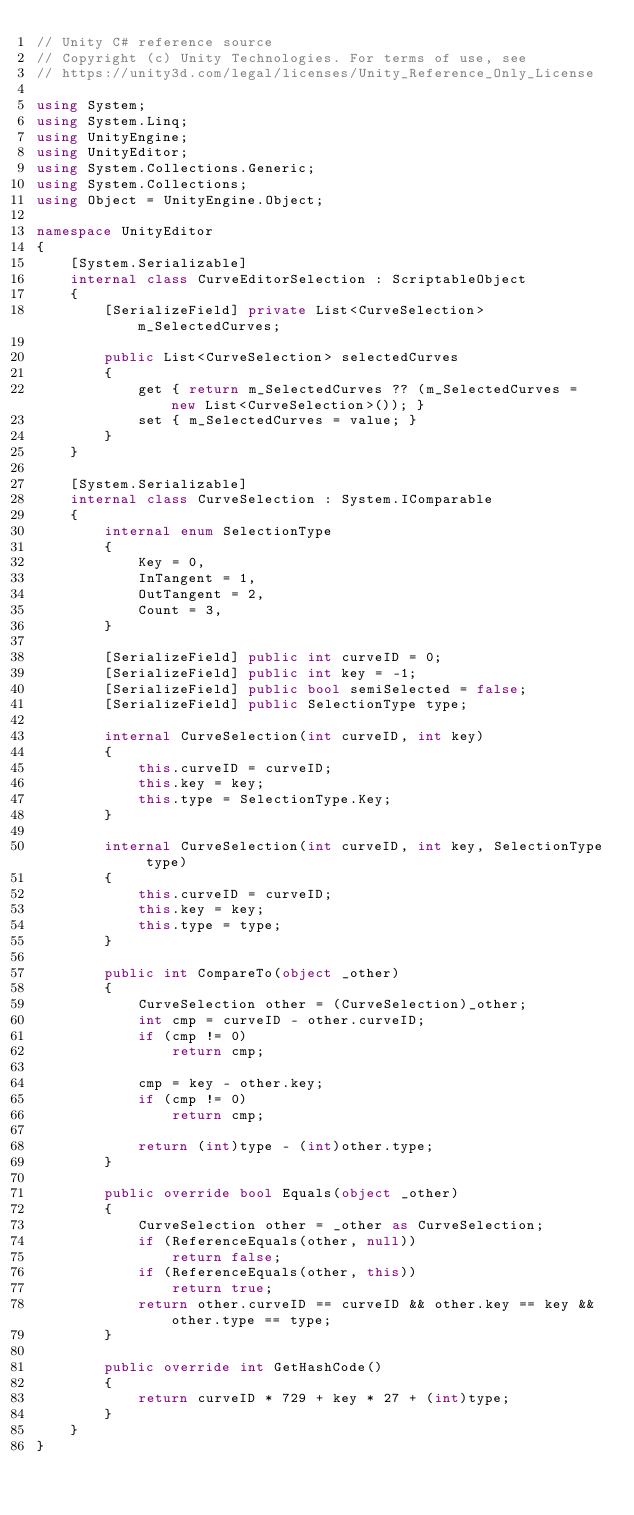Convert code to text. <code><loc_0><loc_0><loc_500><loc_500><_C#_>// Unity C# reference source
// Copyright (c) Unity Technologies. For terms of use, see
// https://unity3d.com/legal/licenses/Unity_Reference_Only_License

using System;
using System.Linq;
using UnityEngine;
using UnityEditor;
using System.Collections.Generic;
using System.Collections;
using Object = UnityEngine.Object;

namespace UnityEditor
{
    [System.Serializable]
    internal class CurveEditorSelection : ScriptableObject
    {
        [SerializeField] private List<CurveSelection> m_SelectedCurves;

        public List<CurveSelection> selectedCurves
        {
            get { return m_SelectedCurves ?? (m_SelectedCurves = new List<CurveSelection>()); }
            set { m_SelectedCurves = value; }
        }
    }

    [System.Serializable]
    internal class CurveSelection : System.IComparable
    {
        internal enum SelectionType
        {
            Key = 0,
            InTangent = 1,
            OutTangent = 2,
            Count = 3,
        }

        [SerializeField] public int curveID = 0;
        [SerializeField] public int key = -1;
        [SerializeField] public bool semiSelected = false;
        [SerializeField] public SelectionType type;

        internal CurveSelection(int curveID, int key)
        {
            this.curveID = curveID;
            this.key = key;
            this.type = SelectionType.Key;
        }

        internal CurveSelection(int curveID, int key, SelectionType type)
        {
            this.curveID = curveID;
            this.key = key;
            this.type = type;
        }

        public int CompareTo(object _other)
        {
            CurveSelection other = (CurveSelection)_other;
            int cmp = curveID - other.curveID;
            if (cmp != 0)
                return cmp;

            cmp = key - other.key;
            if (cmp != 0)
                return cmp;

            return (int)type - (int)other.type;
        }

        public override bool Equals(object _other)
        {
            CurveSelection other = _other as CurveSelection;
            if (ReferenceEquals(other, null))
                return false;
            if (ReferenceEquals(other, this))
                return true;
            return other.curveID == curveID && other.key == key && other.type == type;
        }

        public override int GetHashCode()
        {
            return curveID * 729 + key * 27 + (int)type;
        }
    }
}
</code> 